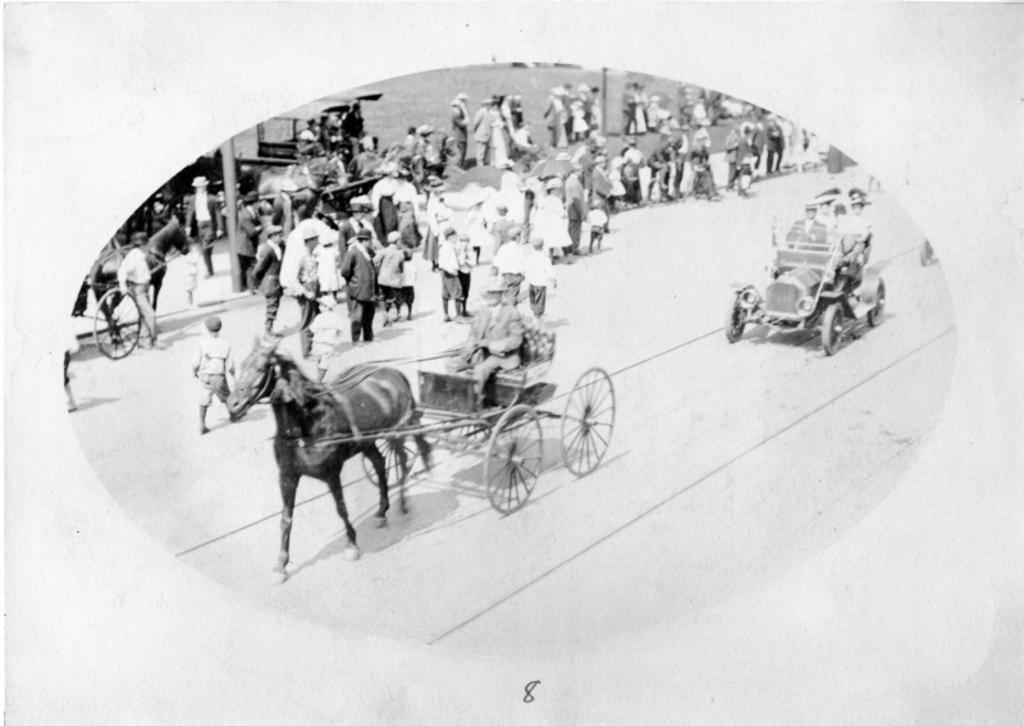What is the color scheme of the image? The image is black and white. What mode of transportation are the people using in the image? The people are traveling on a Tonga, which is a horse-drawn carriage. What type of vehicles can be seen on the road in the image? There are cars on the road in the image. Are there any pedestrians visible in the image? Yes, there are pedestrians walking beside the road in the image. Can you see a tiger walking beside the road in the image? No, there is no tiger present in the image. What type of plastic objects can be seen in the image? There is no plastic object visible in the image. 